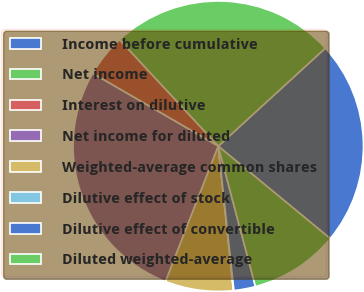Convert chart. <chart><loc_0><loc_0><loc_500><loc_500><pie_chart><fcel>Income before cumulative<fcel>Net income<fcel>Interest on dilutive<fcel>Net income for diluted<fcel>Weighted-average common shares<fcel>Dilutive effect of stock<fcel>Dilutive effect of convertible<fcel>Diluted weighted-average<nl><fcel>22.78%<fcel>25.11%<fcel>4.73%<fcel>27.45%<fcel>7.57%<fcel>0.06%<fcel>2.4%<fcel>9.9%<nl></chart> 